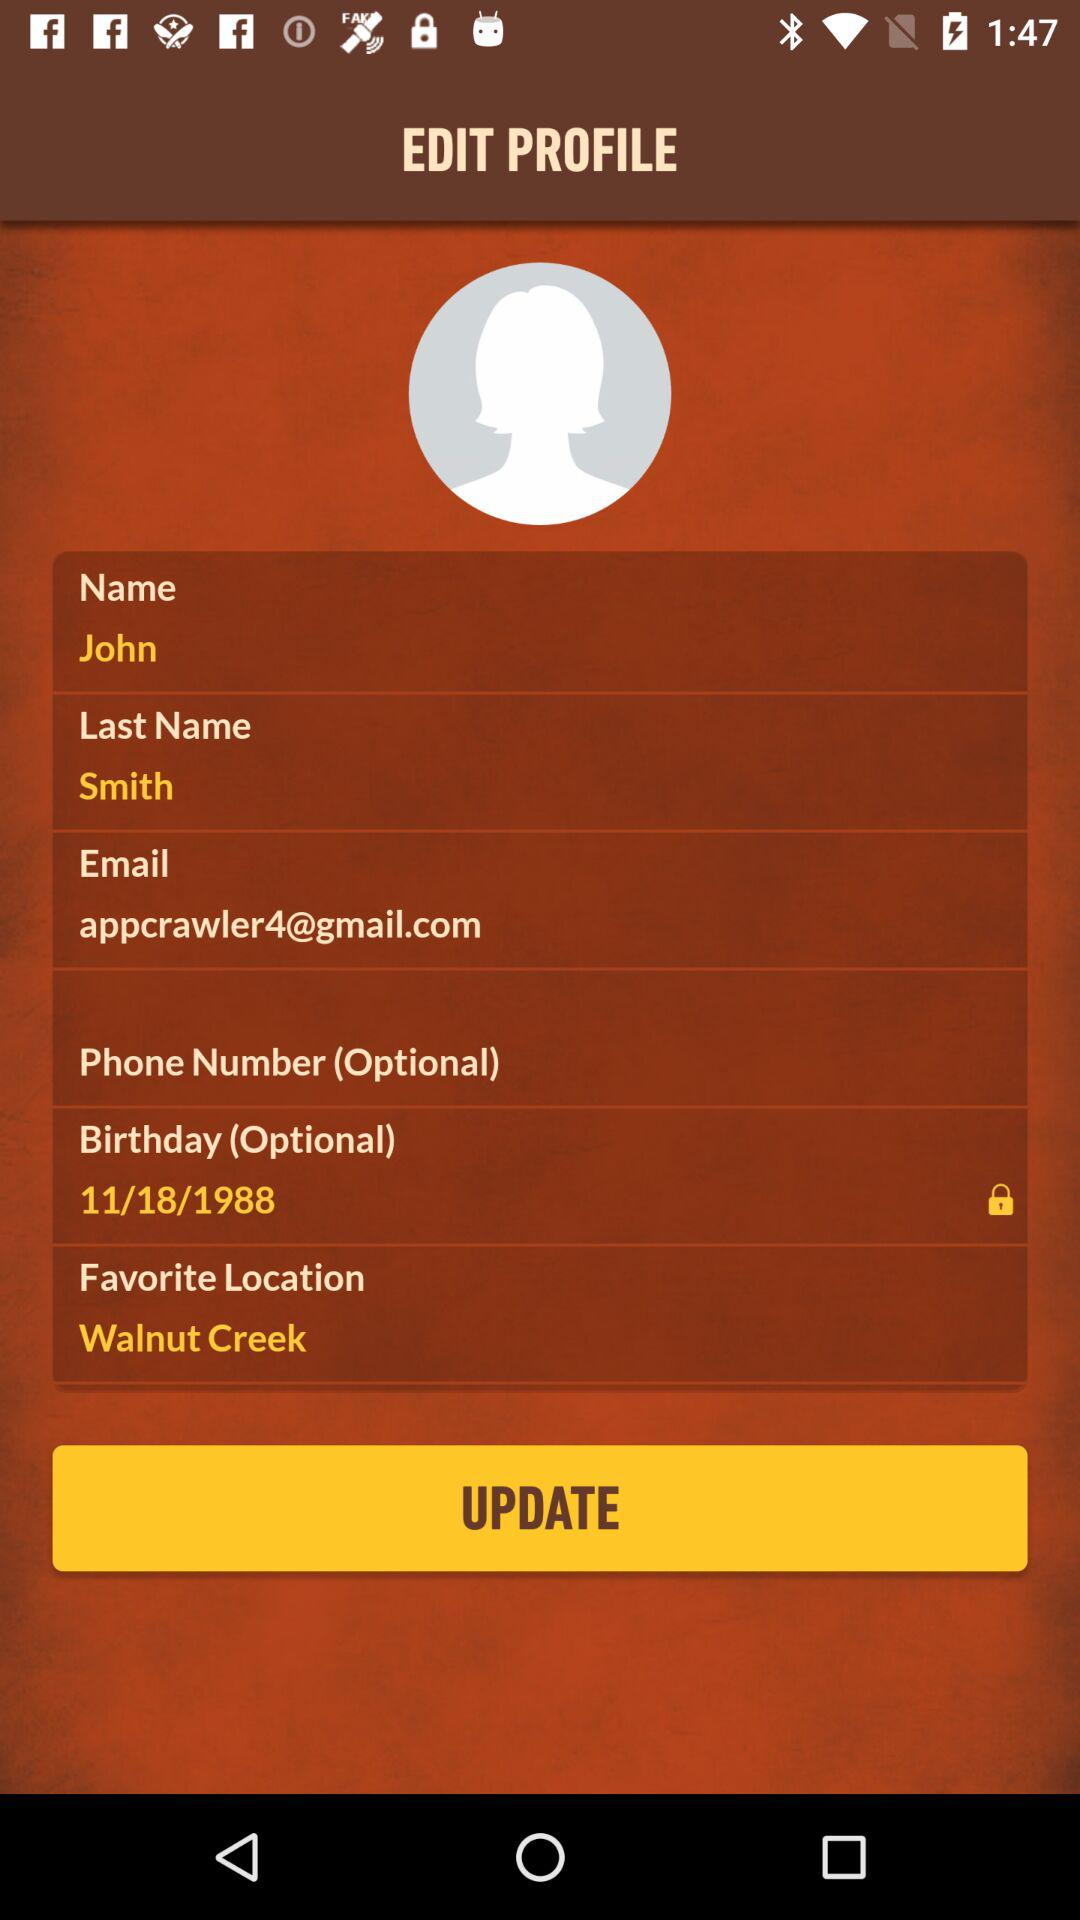What is the given last name? The given last name is Smith. 